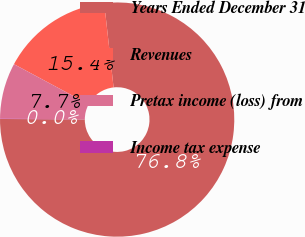<chart> <loc_0><loc_0><loc_500><loc_500><pie_chart><fcel>Years Ended December 31<fcel>Revenues<fcel>Pretax income (loss) from<fcel>Income tax expense<nl><fcel>76.84%<fcel>15.4%<fcel>7.72%<fcel>0.04%<nl></chart> 